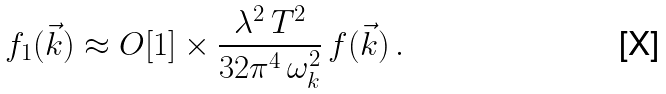Convert formula to latex. <formula><loc_0><loc_0><loc_500><loc_500>f _ { 1 } ( \vec { k } ) \approx O [ 1 ] \times \frac { \lambda ^ { 2 } \, T ^ { 2 } } { 3 2 \pi ^ { 4 } \, \omega _ { k } ^ { 2 } } \, f ( \vec { k } ) \, .</formula> 